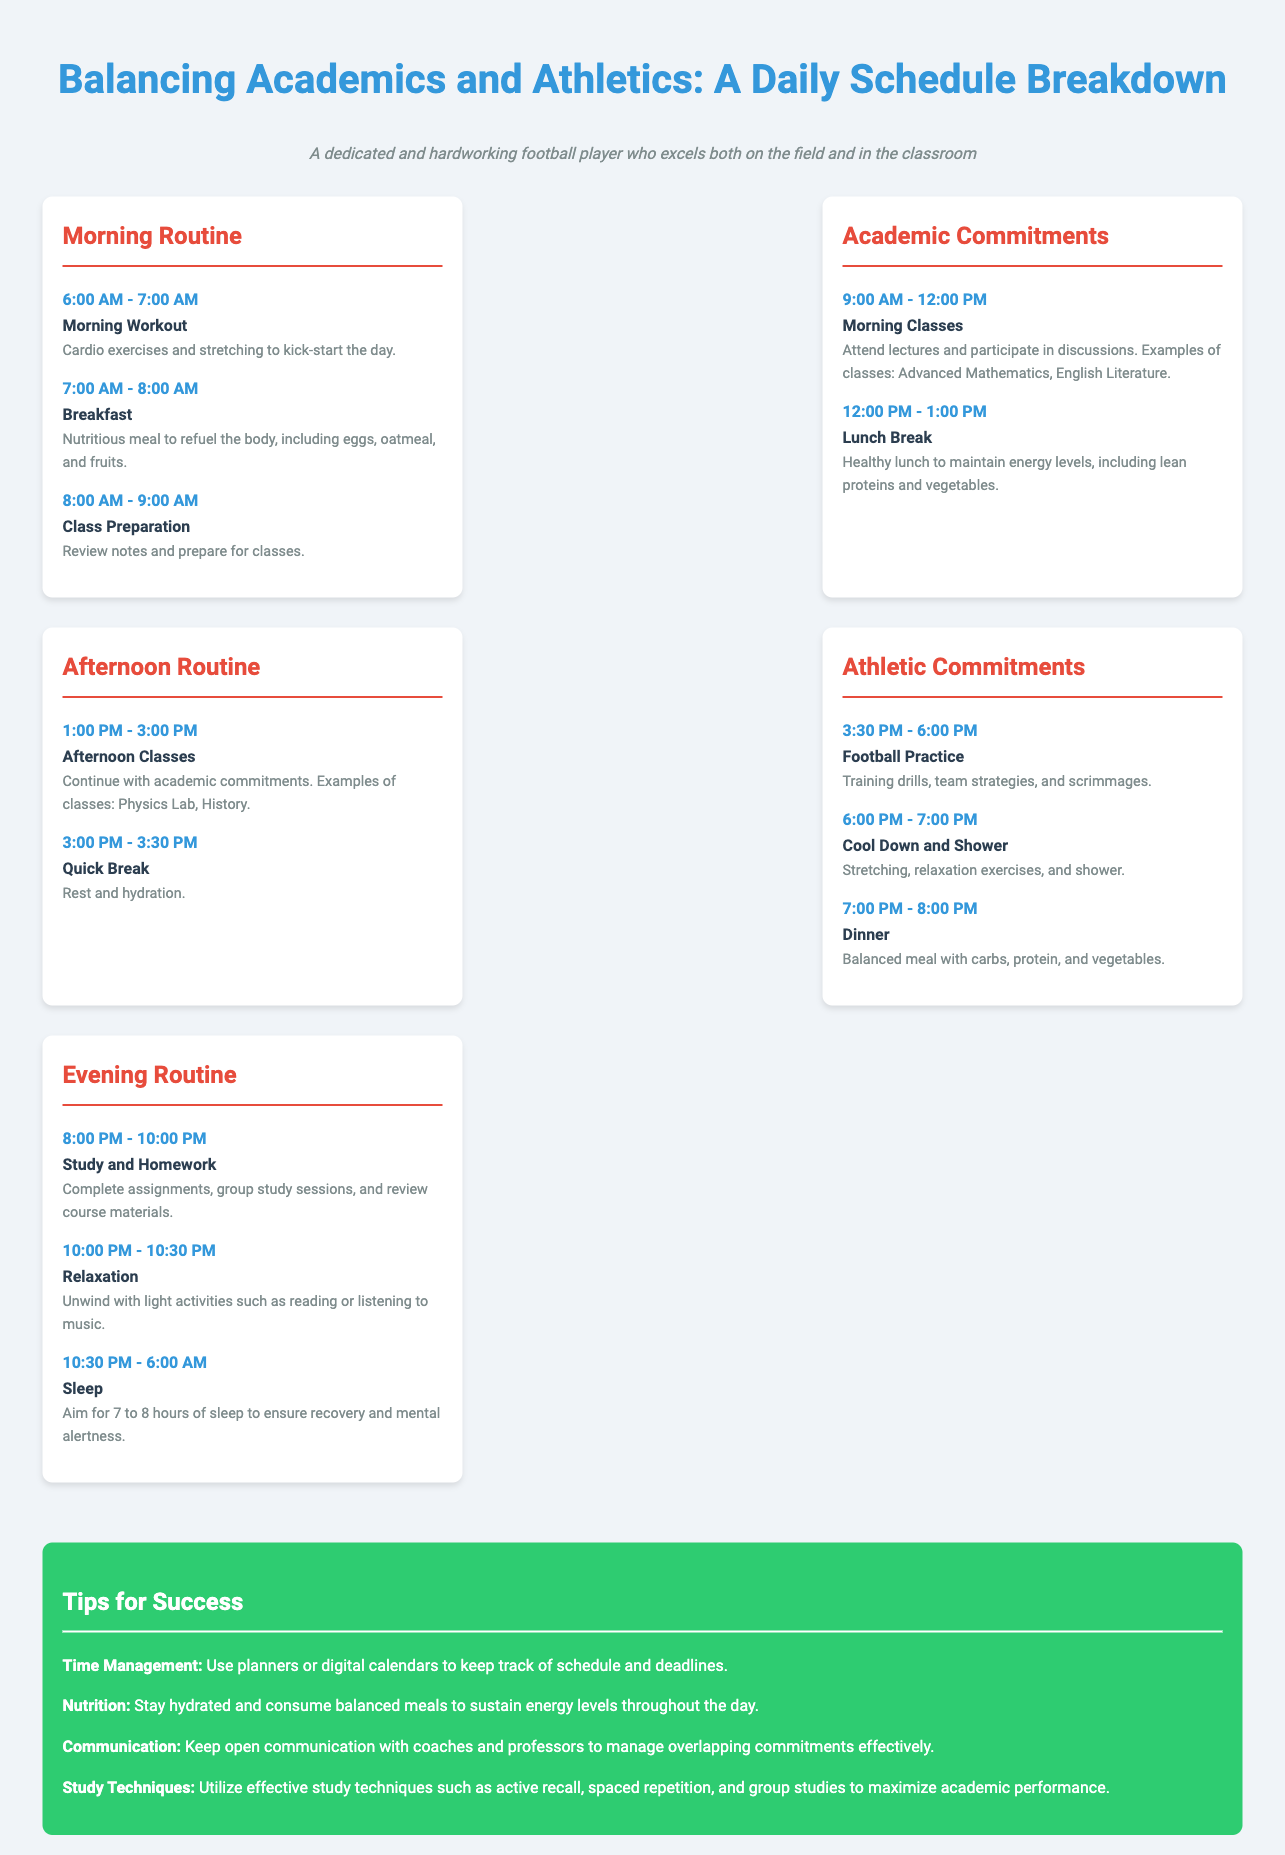What time does the morning workout start? The morning workout starts at 6:00 AM, as listed in the Morning Routine section.
Answer: 6:00 AM What meal is mentioned for breakfast? The breakfast details include eggs, oatmeal, and fruits as nutritious meals to refuel the body.
Answer: Eggs, oatmeal, and fruits How long is the lunch break? The lunch break is one hour long, indicated in the Academic Commitments section.
Answer: 1 hour What is included in the cool down routine? The cool down routine includes stretching and relaxation exercises based on the Athletic Commitments section.
Answer: Stretching and relaxation exercises What type of classes are taken in the afternoon? In the afternoon, classes include examples such as Physics Lab and History, as noted in the Afternoon Routine section.
Answer: Physics Lab, History What activity is scheduled at 10:00 PM? At 10:00 PM, the scheduled activity is relaxation, according to the Evening Routine section.
Answer: Relaxation What is one tip provided for success? One of the tips for success includes time management using planners or digital calendars to keep track of schedules.
Answer: Time Management How many hours of sleep are recommended? The document recommends aiming for 7 to 8 hours of sleep each night for recovery and mental alertness.
Answer: 7 to 8 hours 